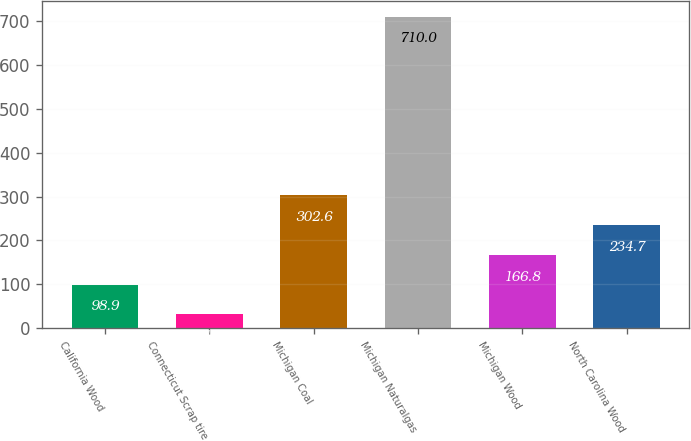<chart> <loc_0><loc_0><loc_500><loc_500><bar_chart><fcel>California Wood<fcel>Connecticut Scrap tire<fcel>Michigan Coal<fcel>Michigan Naturalgas<fcel>Michigan Wood<fcel>North Carolina Wood<nl><fcel>98.9<fcel>31<fcel>302.6<fcel>710<fcel>166.8<fcel>234.7<nl></chart> 